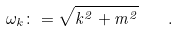<formula> <loc_0><loc_0><loc_500><loc_500>\omega _ { k } \colon = \sqrt { k ^ { 2 } + m ^ { 2 } } \quad .</formula> 